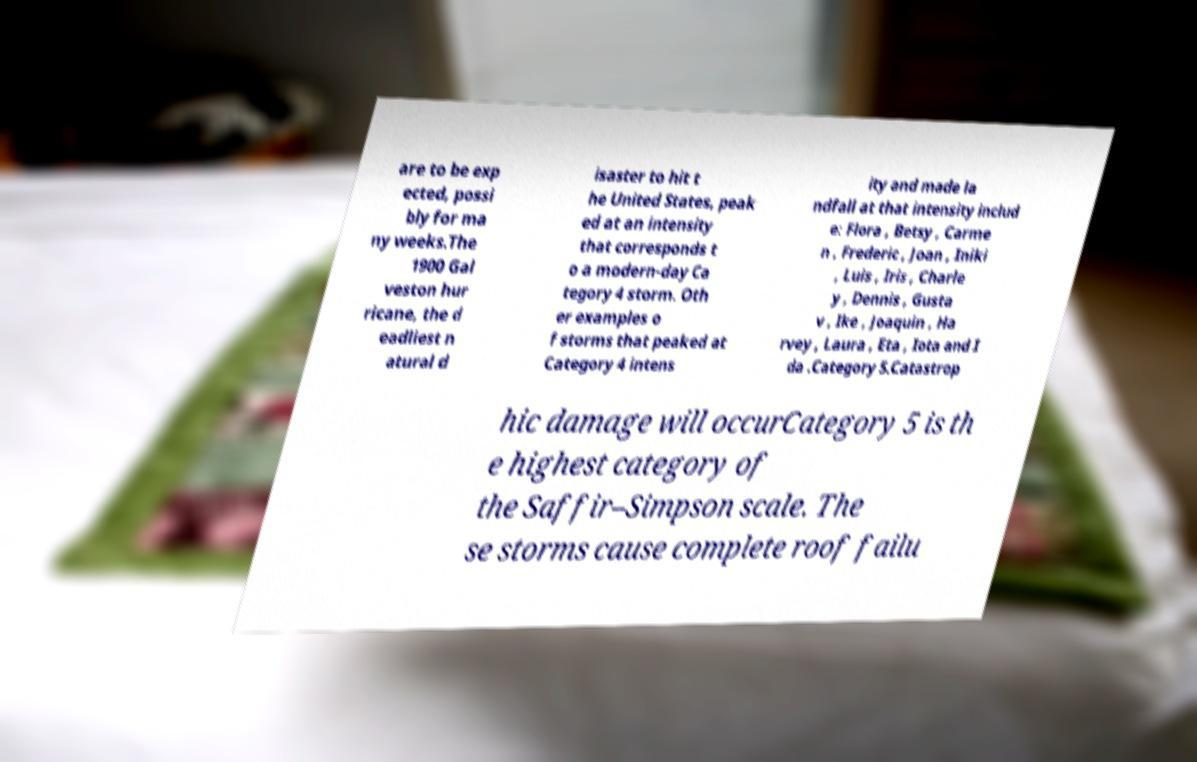Can you accurately transcribe the text from the provided image for me? are to be exp ected, possi bly for ma ny weeks.The 1900 Gal veston hur ricane, the d eadliest n atural d isaster to hit t he United States, peak ed at an intensity that corresponds t o a modern-day Ca tegory 4 storm. Oth er examples o f storms that peaked at Category 4 intens ity and made la ndfall at that intensity includ e: Flora , Betsy , Carme n , Frederic , Joan , Iniki , Luis , Iris , Charle y , Dennis , Gusta v , Ike , Joaquin , Ha rvey , Laura , Eta , Iota and I da .Category 5.Catastrop hic damage will occurCategory 5 is th e highest category of the Saffir–Simpson scale. The se storms cause complete roof failu 